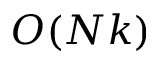Convert formula to latex. <formula><loc_0><loc_0><loc_500><loc_500>O ( N k )</formula> 